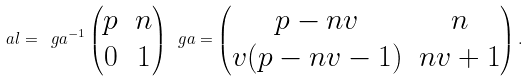<formula> <loc_0><loc_0><loc_500><loc_500>\ a l = \ g a ^ { - 1 } \begin{pmatrix} p & n \\ 0 & 1 \end{pmatrix} \ g a = \begin{pmatrix} p - n v & n \\ v ( p - n v - 1 ) & n v + 1 \end{pmatrix} .</formula> 